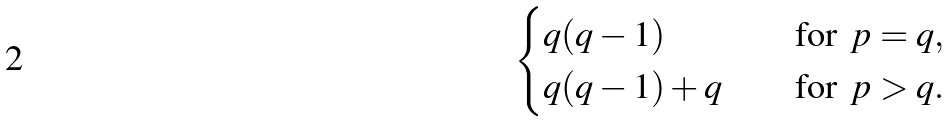<formula> <loc_0><loc_0><loc_500><loc_500>\begin{cases} q ( q - 1 ) \quad & \text {for } \, p = q , \\ q ( q - 1 ) + q \quad & \text {for } \, p > q . \end{cases}</formula> 